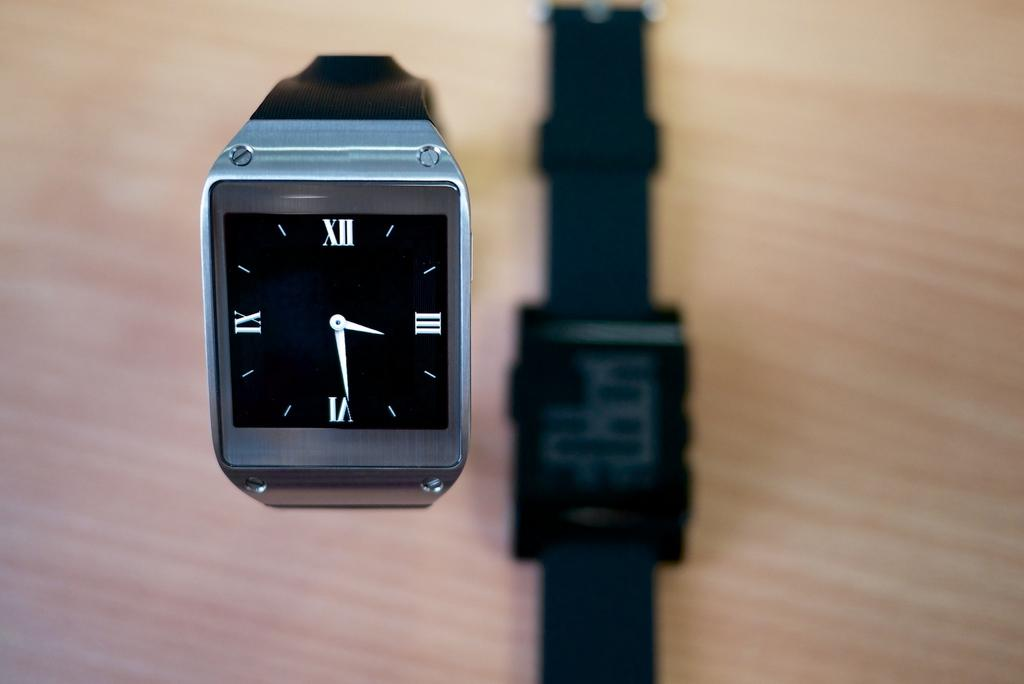<image>
Relay a brief, clear account of the picture shown. an unknown make of wrist watch with only the cardinal roman numerals;XII. III. IV, AND IX 